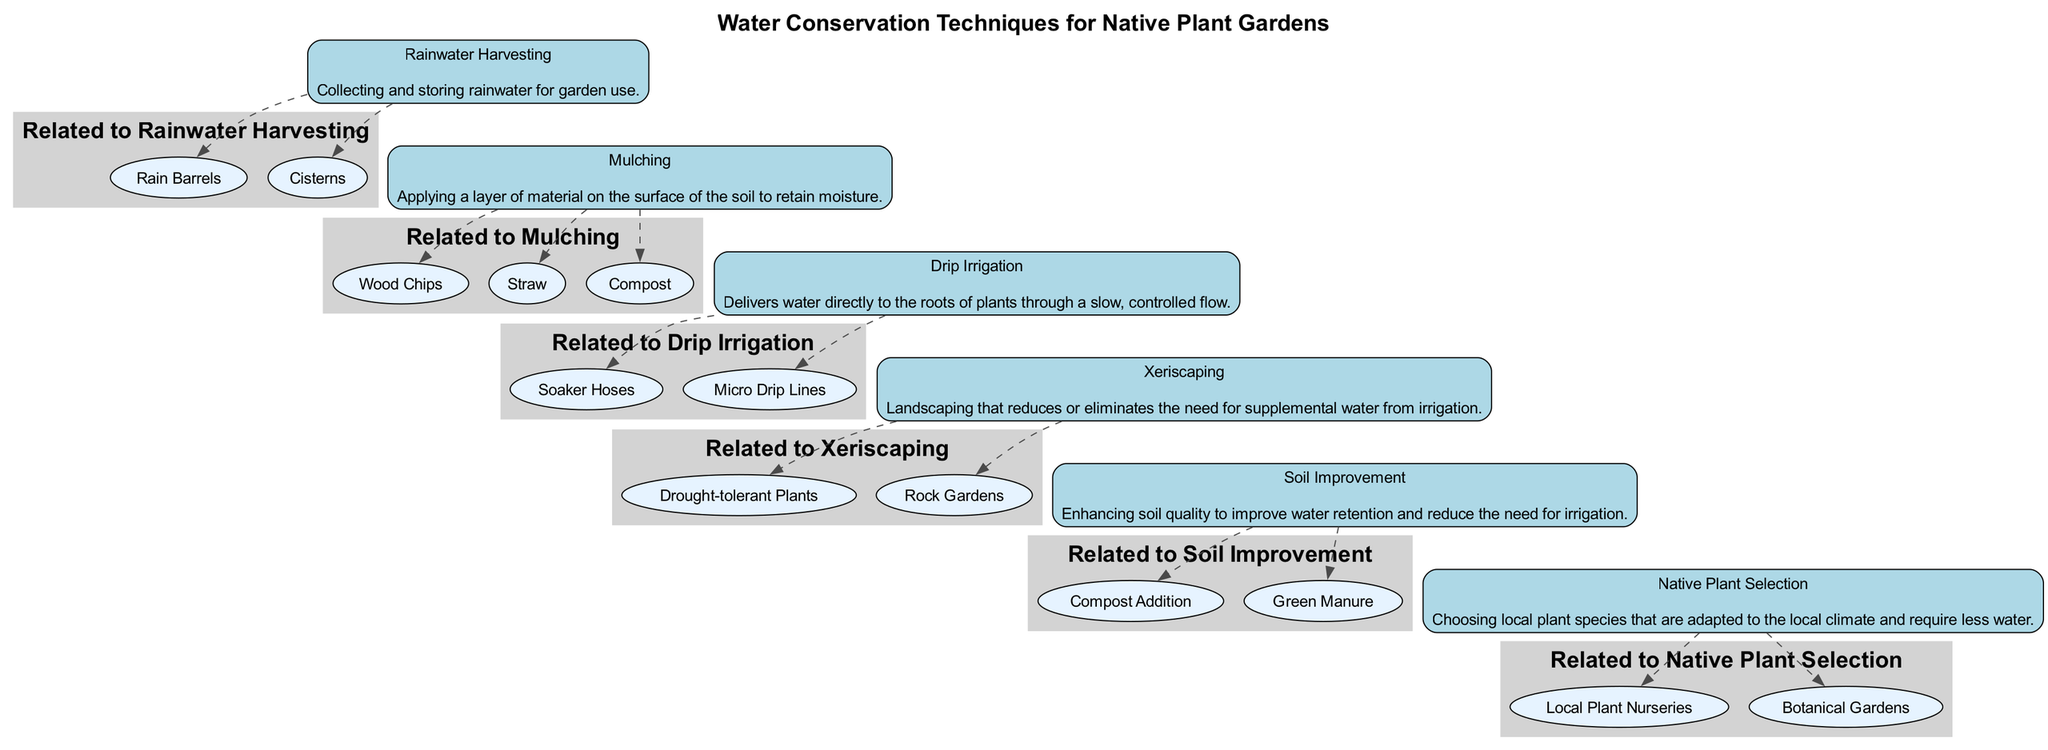What is the first technique listed for water conservation? The first block in the diagram is labeled "Rainwater Harvesting," which indicates it is the first technique presented for water conservation.
Answer: Rainwater Harvesting How many blocks are there in the diagram? Counting the blocks listed in the data, there are a total of six distinct water conservation techniques presented, each represented as a block in the diagram.
Answer: 6 What related entity is associated with "Drip Irrigation"? The block for "Drip Irrigation" has two related entities listed: "Soaker Hoses" and "Micro Drip Lines." Therefore, either of these answers qualifies, but taking the first one, "Soaker Hoses" is associated.
Answer: Soaker Hoses Which technique involves applying a layer of material on the soil? The block labeled "Mulching" describes the action of applying a layer of material on the surface of the soil to retain moisture, thus indicating its primary technique.
Answer: Mulching How many related entities does "Soil Improvement" have? The block for "Soil Improvement" includes two related entities: "Compost Addition" and "Green Manure," so counting these, there are two related entities for this technique.
Answer: 2 What is the purpose of "Xeriscaping"? The description of the "Xeriscaping" block states that it is landscaping that reduces or eliminates the need for supplemental water, thus its primary purpose is to minimize water use in garden design.
Answer: Reduces water need Which two techniques can you associate with local plants? The blocks for "Native Plant Selection" and "Soil Improvement" could both involve the use of local plants, but since "Native Plant Selection" specifically emphasizes choosing local species, it is the more direct association.
Answer: Native Plant Selection What technique uses water delivery directly to plant roots? The block named "Drip Irrigation" explicitly states that it delivers water directly to the roots of plants through a slow, controlled flow, which points out its method of water delivery.
Answer: Drip Irrigation What common theme connects all the strategies in the diagram? The common theme across all blocks is focused on water conservation, as each technique is aimed at reducing water usage in native plant gardens.
Answer: Water conservation 